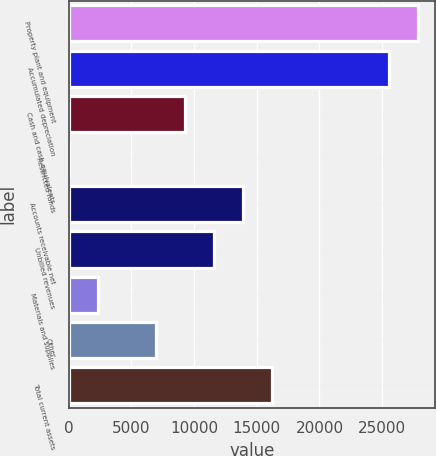Convert chart. <chart><loc_0><loc_0><loc_500><loc_500><bar_chart><fcel>Property plant and equipment<fcel>Accumulated depreciation<fcel>Cash and cash equivalents<fcel>Restricted funds<fcel>Accounts receivable net<fcel>Unbilled revenues<fcel>Materials and supplies<fcel>Other<fcel>Total current assets<nl><fcel>27839.2<fcel>25521.6<fcel>9298.4<fcel>28<fcel>13933.6<fcel>11616<fcel>2345.6<fcel>6980.8<fcel>16251.2<nl></chart> 